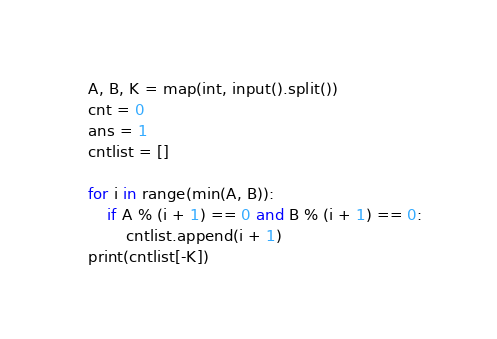<code> <loc_0><loc_0><loc_500><loc_500><_Python_>A, B, K = map(int, input().split())
cnt = 0
ans = 1
cntlist = []

for i in range(min(A, B)):
    if A % (i + 1) == 0 and B % (i + 1) == 0:
        cntlist.append(i + 1)
print(cntlist[-K])</code> 